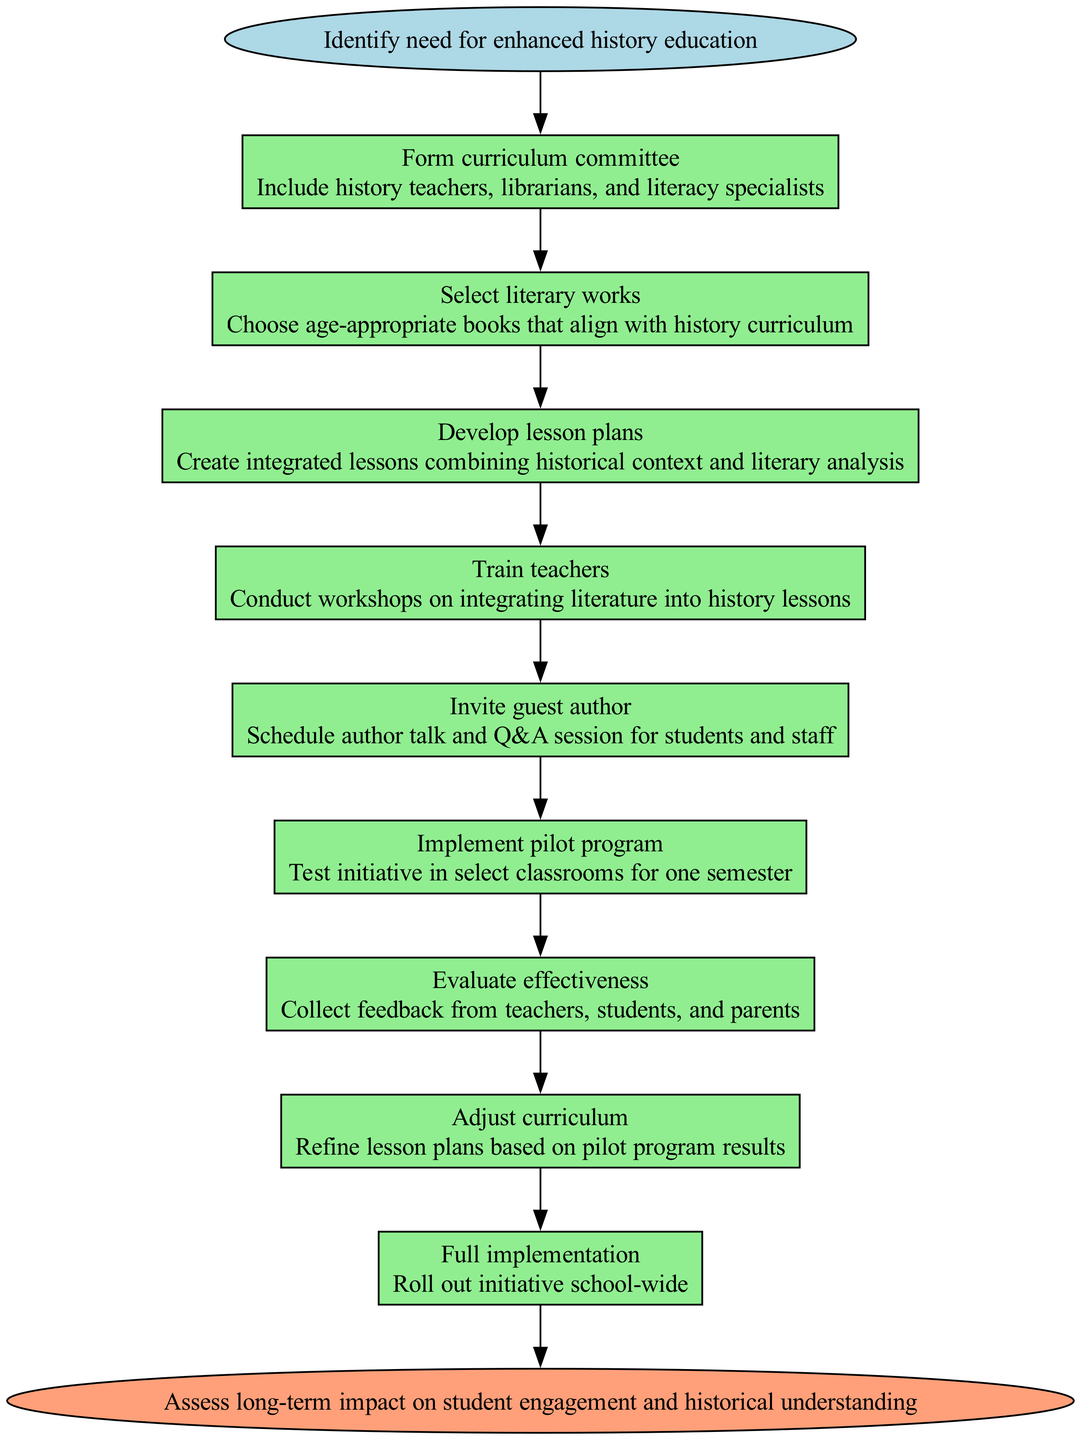What is the first step in the pathway? The first step in the pathway is labeled as "Identify need for enhanced history education." This is indicated as the initial node connected to the following steps in the diagram.
Answer: Identify need for enhanced history education How many steps are included in the pathway? The diagram lists a total of eight steps, from forming the curriculum committee to full implementation. Each step is displayed in a rectangular node format, and they sequentially connect from the start to the end.
Answer: 8 What is the last step before assessing the long-term impact? The last step before the end node is "Full implementation," which is the final action taken to roll out the initiative school-wide. This step connects directly to the endpoint of the pathway.
Answer: Full implementation What type of specialists are included in the curriculum committee? The diagram specifies that the curriculum committee should include history teachers, librarians, and literacy specialists, making these the key roles highlighted in the step.
Answer: history teachers, librarians, and literacy specialists What action is taken after training teachers? After training teachers, the next action is "Invite guest author," which is the following step in the pathway listed after training. The steps flow from one to the next in a sequential manner.
Answer: Invite guest author Which step involves collecting feedback? The step that involves collecting feedback is "Evaluate effectiveness." This is specifically mentioned in the details under that step in the diagram as gathering input from teachers, students, and parents.
Answer: Evaluate effectiveness What is the purpose of the pilot program? The purpose of the pilot program is to "Test initiative in select classrooms for one semester," which aims to assess the viability of the integrated approach before a broader rollout. This step provides critical information for the subsequent evaluation.
Answer: Test initiative in select classrooms for one semester How many nodes connect directly to the end node? There is one node that connects directly to the end node, which is "Full implementation." This means that only this step directly leads to the final outcome in the clinical pathway diagram.
Answer: 1 